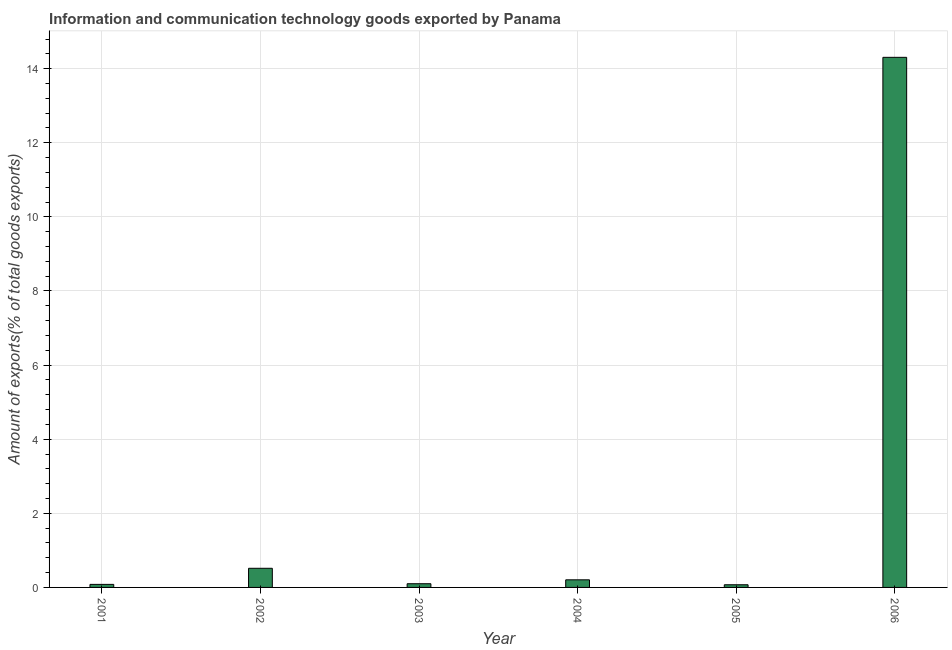Does the graph contain grids?
Give a very brief answer. Yes. What is the title of the graph?
Offer a terse response. Information and communication technology goods exported by Panama. What is the label or title of the Y-axis?
Provide a short and direct response. Amount of exports(% of total goods exports). What is the amount of ict goods exports in 2005?
Your answer should be compact. 0.07. Across all years, what is the maximum amount of ict goods exports?
Your answer should be very brief. 14.31. Across all years, what is the minimum amount of ict goods exports?
Offer a very short reply. 0.07. In which year was the amount of ict goods exports maximum?
Ensure brevity in your answer.  2006. In which year was the amount of ict goods exports minimum?
Give a very brief answer. 2005. What is the sum of the amount of ict goods exports?
Give a very brief answer. 15.28. What is the difference between the amount of ict goods exports in 2001 and 2005?
Give a very brief answer. 0.01. What is the average amount of ict goods exports per year?
Keep it short and to the point. 2.55. What is the median amount of ict goods exports?
Give a very brief answer. 0.15. Do a majority of the years between 2003 and 2005 (inclusive) have amount of ict goods exports greater than 2.8 %?
Offer a very short reply. No. What is the ratio of the amount of ict goods exports in 2002 to that in 2006?
Make the answer very short. 0.04. Is the difference between the amount of ict goods exports in 2001 and 2004 greater than the difference between any two years?
Provide a short and direct response. No. What is the difference between the highest and the second highest amount of ict goods exports?
Offer a very short reply. 13.79. Is the sum of the amount of ict goods exports in 2002 and 2004 greater than the maximum amount of ict goods exports across all years?
Your answer should be compact. No. What is the difference between the highest and the lowest amount of ict goods exports?
Make the answer very short. 14.23. Are all the bars in the graph horizontal?
Your response must be concise. No. How many years are there in the graph?
Make the answer very short. 6. What is the Amount of exports(% of total goods exports) of 2001?
Ensure brevity in your answer.  0.08. What is the Amount of exports(% of total goods exports) of 2002?
Make the answer very short. 0.52. What is the Amount of exports(% of total goods exports) in 2003?
Make the answer very short. 0.1. What is the Amount of exports(% of total goods exports) in 2004?
Keep it short and to the point. 0.21. What is the Amount of exports(% of total goods exports) of 2005?
Your answer should be very brief. 0.07. What is the Amount of exports(% of total goods exports) of 2006?
Ensure brevity in your answer.  14.31. What is the difference between the Amount of exports(% of total goods exports) in 2001 and 2002?
Provide a succinct answer. -0.43. What is the difference between the Amount of exports(% of total goods exports) in 2001 and 2003?
Make the answer very short. -0.02. What is the difference between the Amount of exports(% of total goods exports) in 2001 and 2004?
Provide a succinct answer. -0.12. What is the difference between the Amount of exports(% of total goods exports) in 2001 and 2005?
Make the answer very short. 0.01. What is the difference between the Amount of exports(% of total goods exports) in 2001 and 2006?
Give a very brief answer. -14.22. What is the difference between the Amount of exports(% of total goods exports) in 2002 and 2003?
Keep it short and to the point. 0.42. What is the difference between the Amount of exports(% of total goods exports) in 2002 and 2004?
Keep it short and to the point. 0.31. What is the difference between the Amount of exports(% of total goods exports) in 2002 and 2005?
Your answer should be very brief. 0.44. What is the difference between the Amount of exports(% of total goods exports) in 2002 and 2006?
Offer a very short reply. -13.79. What is the difference between the Amount of exports(% of total goods exports) in 2003 and 2004?
Offer a very short reply. -0.11. What is the difference between the Amount of exports(% of total goods exports) in 2003 and 2005?
Provide a short and direct response. 0.03. What is the difference between the Amount of exports(% of total goods exports) in 2003 and 2006?
Give a very brief answer. -14.21. What is the difference between the Amount of exports(% of total goods exports) in 2004 and 2005?
Provide a short and direct response. 0.13. What is the difference between the Amount of exports(% of total goods exports) in 2004 and 2006?
Your answer should be very brief. -14.1. What is the difference between the Amount of exports(% of total goods exports) in 2005 and 2006?
Your answer should be compact. -14.23. What is the ratio of the Amount of exports(% of total goods exports) in 2001 to that in 2002?
Keep it short and to the point. 0.16. What is the ratio of the Amount of exports(% of total goods exports) in 2001 to that in 2003?
Make the answer very short. 0.82. What is the ratio of the Amount of exports(% of total goods exports) in 2001 to that in 2005?
Keep it short and to the point. 1.14. What is the ratio of the Amount of exports(% of total goods exports) in 2001 to that in 2006?
Your answer should be compact. 0.01. What is the ratio of the Amount of exports(% of total goods exports) in 2002 to that in 2003?
Your answer should be compact. 5.18. What is the ratio of the Amount of exports(% of total goods exports) in 2002 to that in 2004?
Offer a very short reply. 2.52. What is the ratio of the Amount of exports(% of total goods exports) in 2002 to that in 2005?
Provide a succinct answer. 7.17. What is the ratio of the Amount of exports(% of total goods exports) in 2002 to that in 2006?
Provide a succinct answer. 0.04. What is the ratio of the Amount of exports(% of total goods exports) in 2003 to that in 2004?
Your response must be concise. 0.49. What is the ratio of the Amount of exports(% of total goods exports) in 2003 to that in 2005?
Provide a short and direct response. 1.39. What is the ratio of the Amount of exports(% of total goods exports) in 2003 to that in 2006?
Your answer should be very brief. 0.01. What is the ratio of the Amount of exports(% of total goods exports) in 2004 to that in 2005?
Your answer should be compact. 2.85. What is the ratio of the Amount of exports(% of total goods exports) in 2004 to that in 2006?
Keep it short and to the point. 0.01. What is the ratio of the Amount of exports(% of total goods exports) in 2005 to that in 2006?
Offer a very short reply. 0.01. 